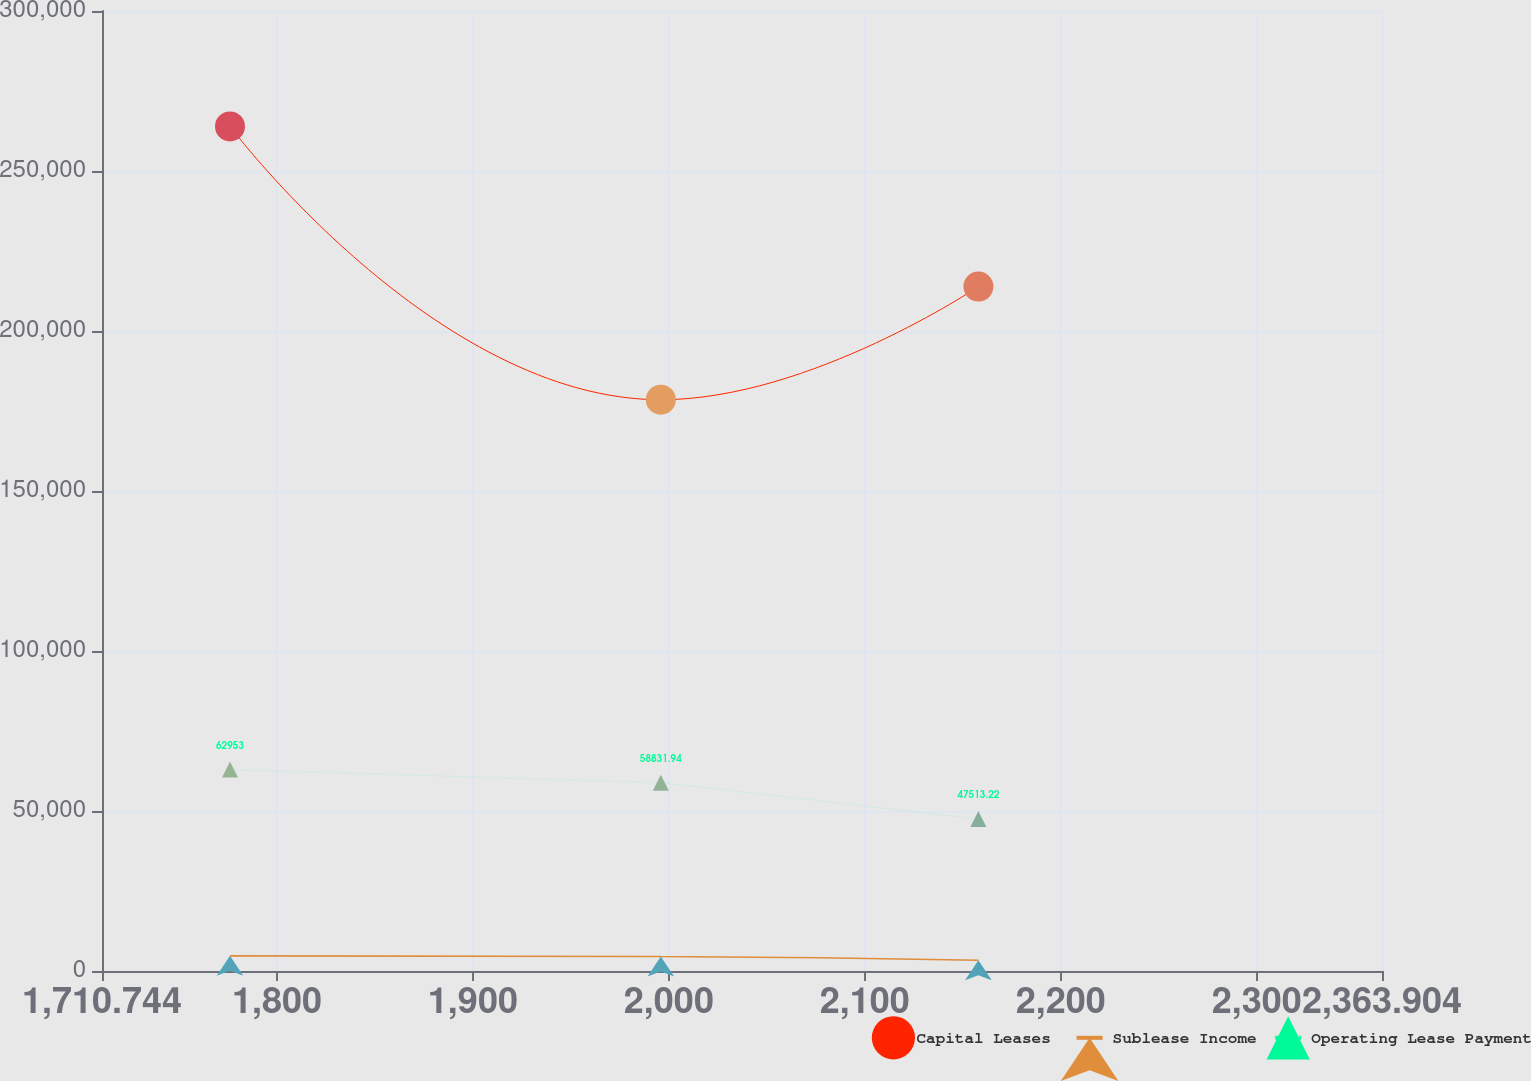<chart> <loc_0><loc_0><loc_500><loc_500><line_chart><ecel><fcel>Capital Leases<fcel>Sublease Income<fcel>Operating Lease Payment<nl><fcel>1776.06<fcel>263942<fcel>4734.87<fcel>62953<nl><fcel>1995.9<fcel>178522<fcel>4528.93<fcel>58831.9<nl><fcel>2157.95<fcel>213870<fcel>3346.3<fcel>47513.2<nl><fcel>2367.68<fcel>187064<fcel>2539.84<fcel>36804.5<nl><fcel>2429.22<fcel>195606<fcel>3140.36<fcel>20566.8<nl></chart> 